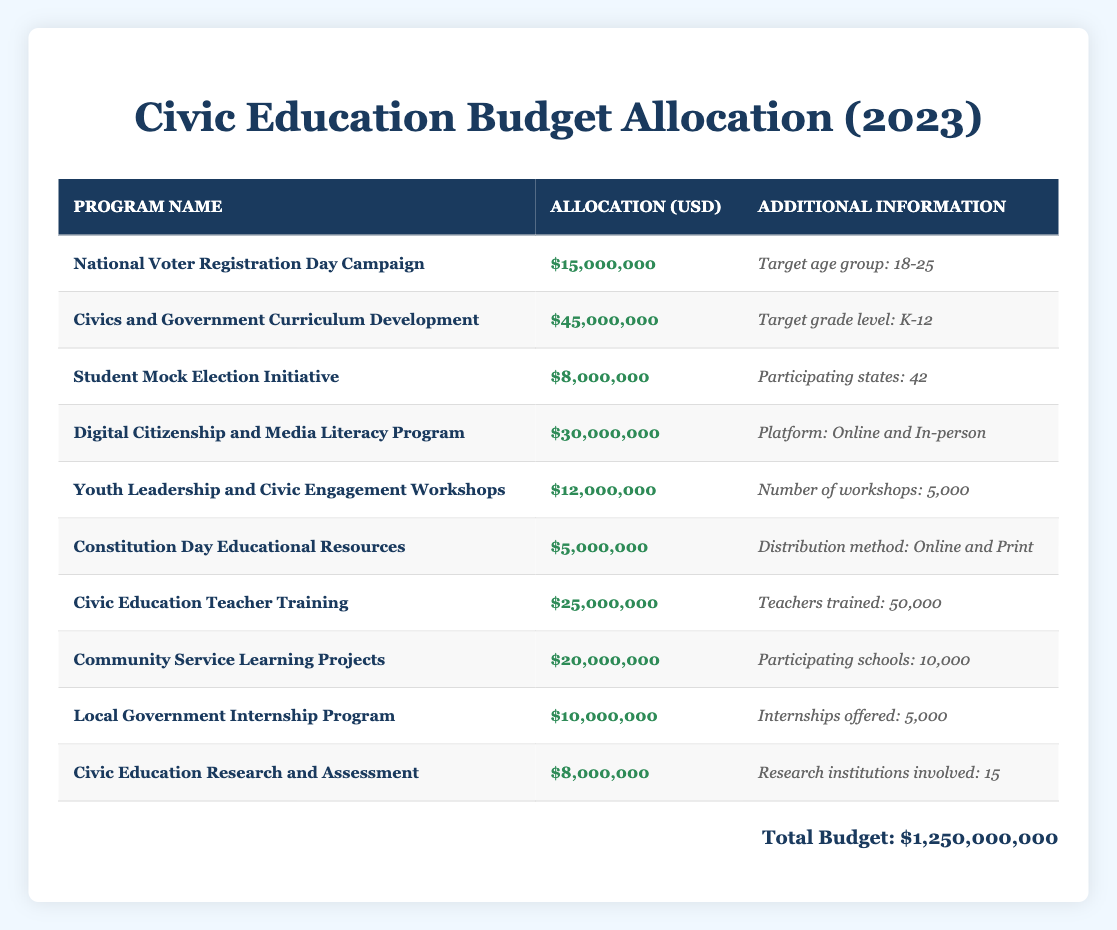What is the total allocation for the Civics and Government Curriculum Development program? The allocation for the Civics and Government Curriculum Development program is listed directly in the table as $45,000,000.
Answer: $45,000,000 How many workshops are planned under the Youth Leadership and Civic Engagement Workshops program? The number of workshops planned under the Youth Leadership and Civic Engagement Workshops program is specifically mentioned in the table as 5,000.
Answer: 5,000 What is the total budget allocated to programs targeting students aged 18-25? The only program targeting the age group of 18-25 is the National Voter Registration Day Campaign, which has an allocation of $15,000,000. Therefore, the total budget for this target age group is $15,000,000.
Answer: $15,000,000 Is there a program that trains teachers, and if so, what is its budget? Yes, there is a program named Civic Education Teacher Training that trains teachers, and its budget is specified as $25,000,000 in the table.
Answer: Yes, $25,000,000 What percentage of the total budget does the Digital Citizenship and Media Literacy Program represent? To find the percentage, divide the allocation for the Digital Citizenship and Media Literacy Program ($30,000,000) by the total budget ($1,250,000,000) and multiply by 100. The calculation is (30,000,000 / 1,250,000,000) * 100 = 2.4%.
Answer: 2.4% What is the total amount allocated to programs focused on community service learning? The programs related to community service learning are Community Service Learning Projects (allocation: $20,000,000) and the Local Government Internship Program (allocation: $10,000,000). Summing these gives: $20,000,000 + $10,000,000 = $30,000,000 allocated to community service learning.
Answer: $30,000,000 Which program has the smallest budget, and what is the amount? The program with the smallest budget according to the table is the Constitution Day Educational Resources, which has an allocation of $5,000,000.
Answer: Constitution Day Educational Resources, $5,000,000 How many states participate in the Student Mock Election Initiative, and is this information confirmed in the table? The number of participating states in the Student Mock Election Initiative is given as 42 in the table, confirming this information as correct.
Answer: Yes, 42 What is the combined budget for programs related to digital citizenship and civic engagement? The relevant programs are the Digital Citizenship and Media Literacy Program ($30,000,000) and the Youth Leadership and Civic Engagement Workshops ($12,000,000). Combining these amounts gives: $30,000,000 + $12,000,000 = $42,000,000 allocated to digital citizenship and civic engagement.
Answer: $42,000,000 